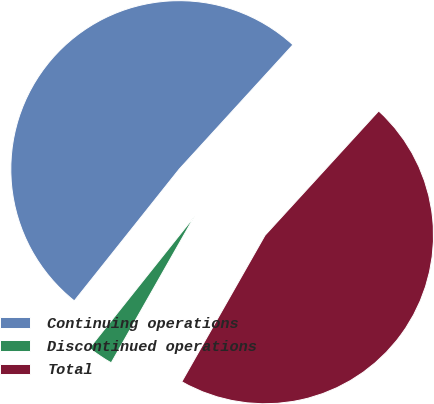Convert chart to OTSL. <chart><loc_0><loc_0><loc_500><loc_500><pie_chart><fcel>Continuing operations<fcel>Discontinued operations<fcel>Total<nl><fcel>51.08%<fcel>2.48%<fcel>46.44%<nl></chart> 